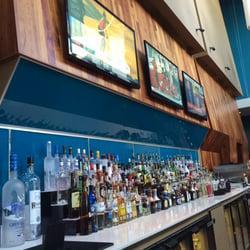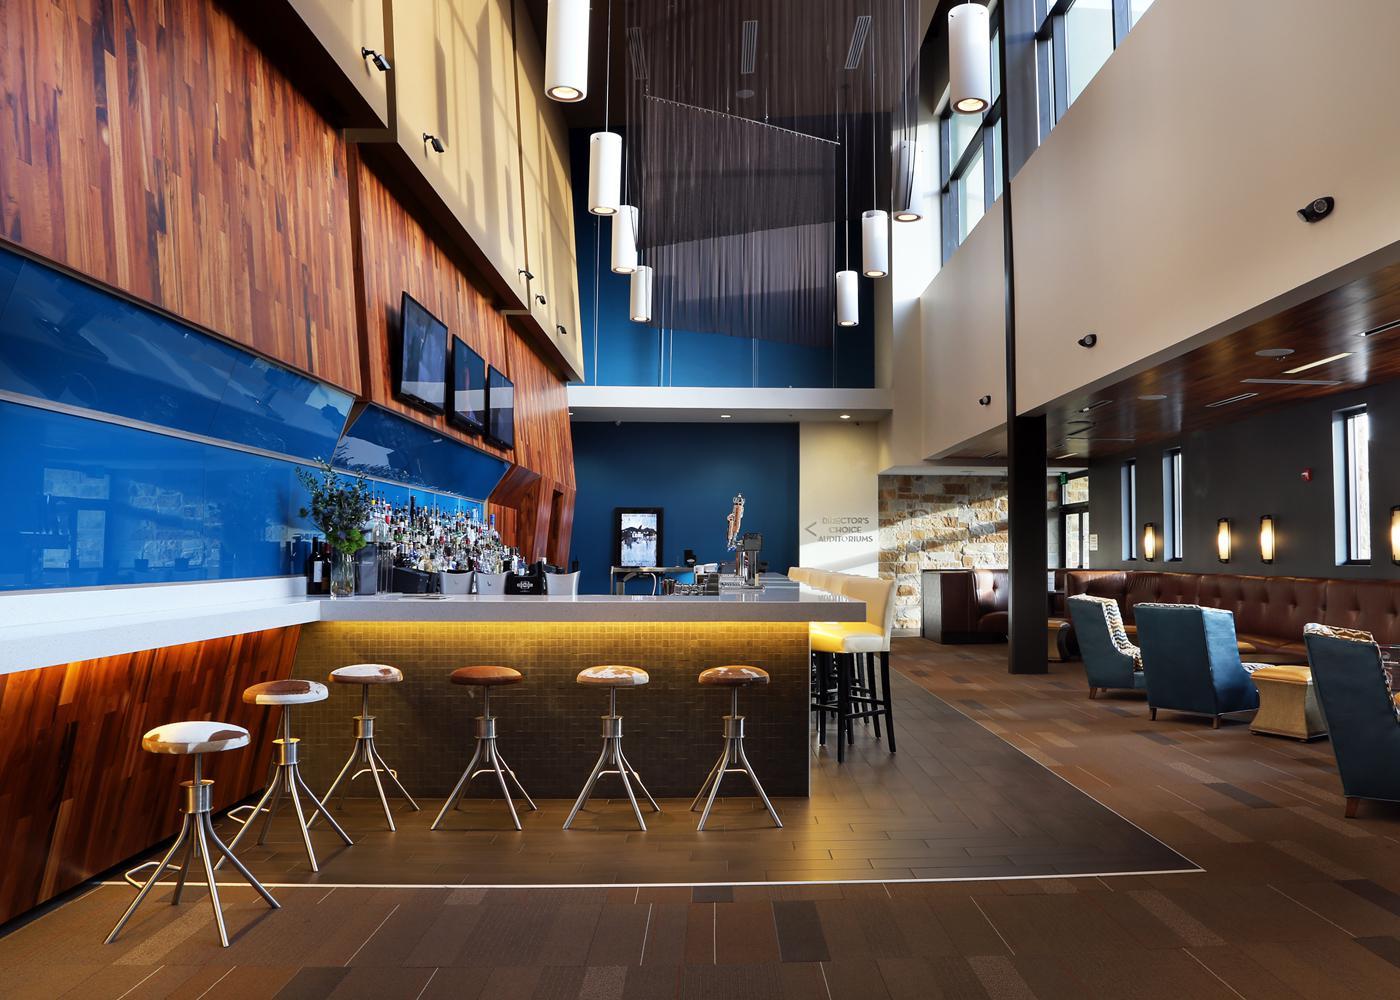The first image is the image on the left, the second image is the image on the right. Given the left and right images, does the statement "Signage hangs above the entrance of the place in the image on the right." hold true? Answer yes or no. No. The first image is the image on the left, the second image is the image on the right. Evaluate the accuracy of this statement regarding the images: "The right image shows an interior with backless stools leading to white chair-type stools at a bar with glowing yellow underlighting.". Is it true? Answer yes or no. Yes. 